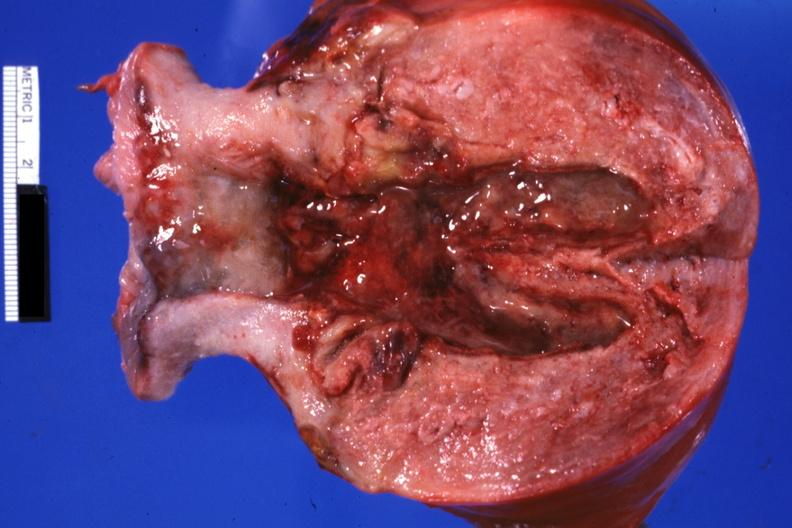why does this image show opened cervix and endometrium with necrotic tissue five weeks post section?
Answer the question using a single word or phrase. Because of brain hemorrhage 40 gestation 29 yo hypertensive bf 